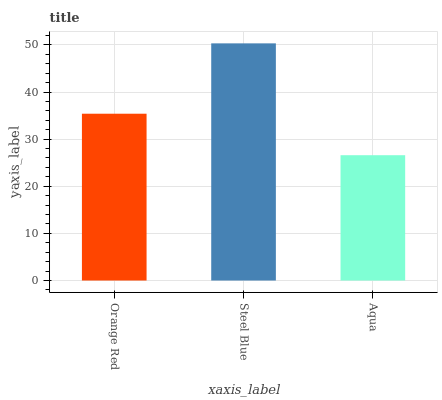Is Steel Blue the minimum?
Answer yes or no. No. Is Aqua the maximum?
Answer yes or no. No. Is Steel Blue greater than Aqua?
Answer yes or no. Yes. Is Aqua less than Steel Blue?
Answer yes or no. Yes. Is Aqua greater than Steel Blue?
Answer yes or no. No. Is Steel Blue less than Aqua?
Answer yes or no. No. Is Orange Red the high median?
Answer yes or no. Yes. Is Orange Red the low median?
Answer yes or no. Yes. Is Aqua the high median?
Answer yes or no. No. Is Steel Blue the low median?
Answer yes or no. No. 